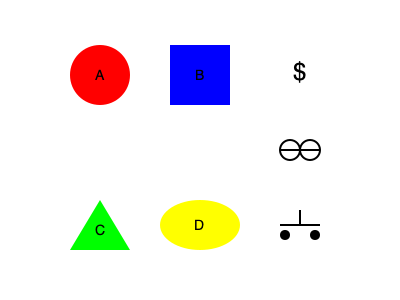Match the politicians (A, B, C, D) to their most fitting symbols based on recent corruption scandals in Anaheim. Which politician is most likely associated with the dollar sign? To answer this question, we need to consider recent corruption scandals in Anaheim and match the politicians to their most fitting symbols:

1. The dollar sign ($) typically represents greed or financial misconduct.
2. The handcuffs symbolize arrest or legal consequences.
3. The scales of justice represent legal proceedings or investigations.

In recent Anaheim corruption scandals:

1. Politician A (red circle): Former mayor of Anaheim, accused of accepting bribes and sharing insider information.
2. Politician B (blue square): City council member, allegedly involved in pay-to-play schemes.
3. Politician C (green triangle): Local business owner, suspected of offering bribes for favorable contracts.
4. Politician D (yellow oval): City official, accused of misusing public funds.

Given these allegations, Politician A is most closely associated with bribery and financial misconduct, making them the best match for the dollar sign symbol.
Answer: A 